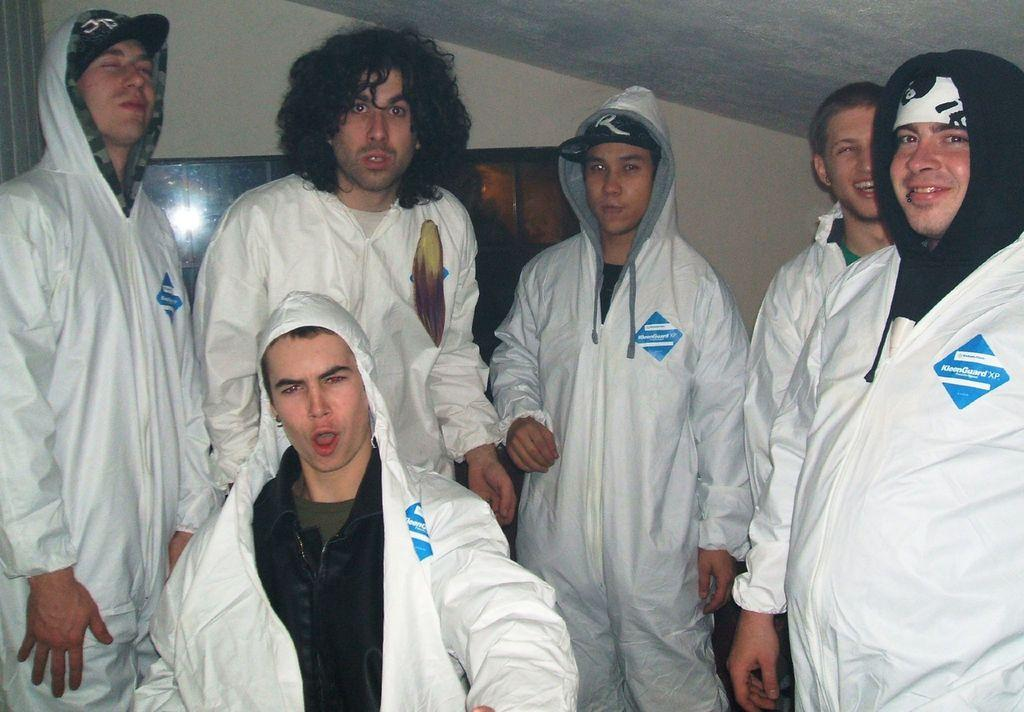<image>
Create a compact narrative representing the image presented. the word guard that is on a blue patch 